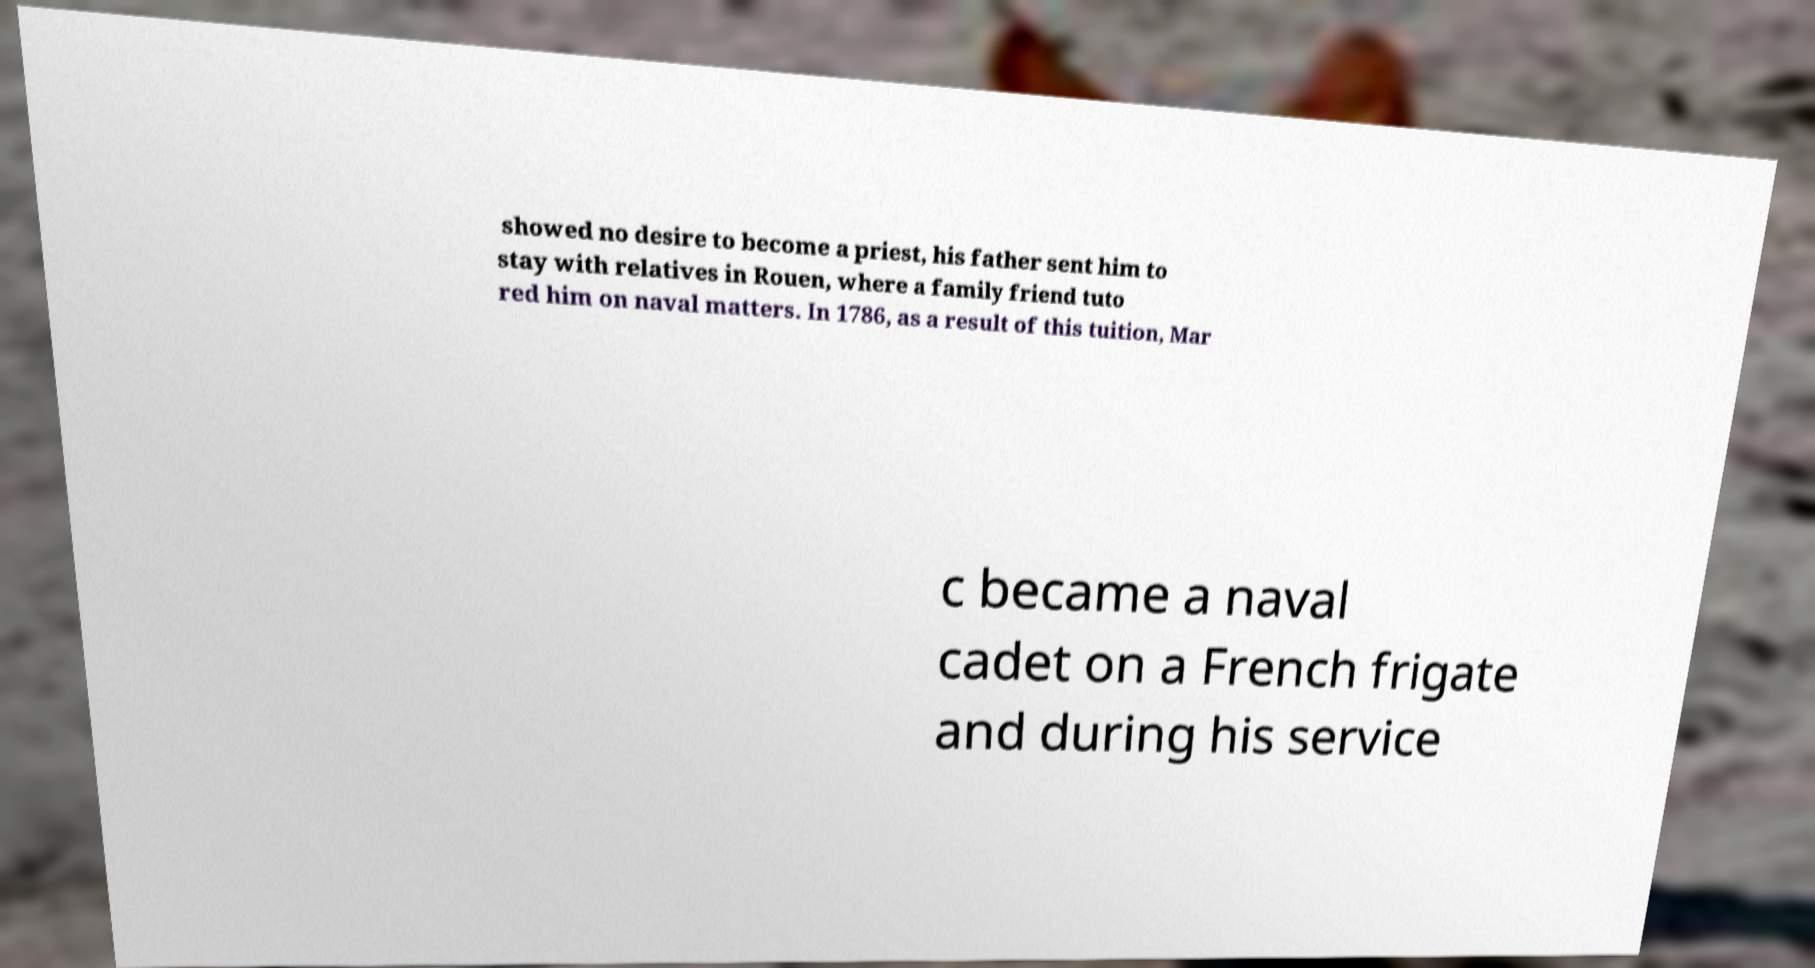Could you assist in decoding the text presented in this image and type it out clearly? showed no desire to become a priest, his father sent him to stay with relatives in Rouen, where a family friend tuto red him on naval matters. In 1786, as a result of this tuition, Mar c became a naval cadet on a French frigate and during his service 